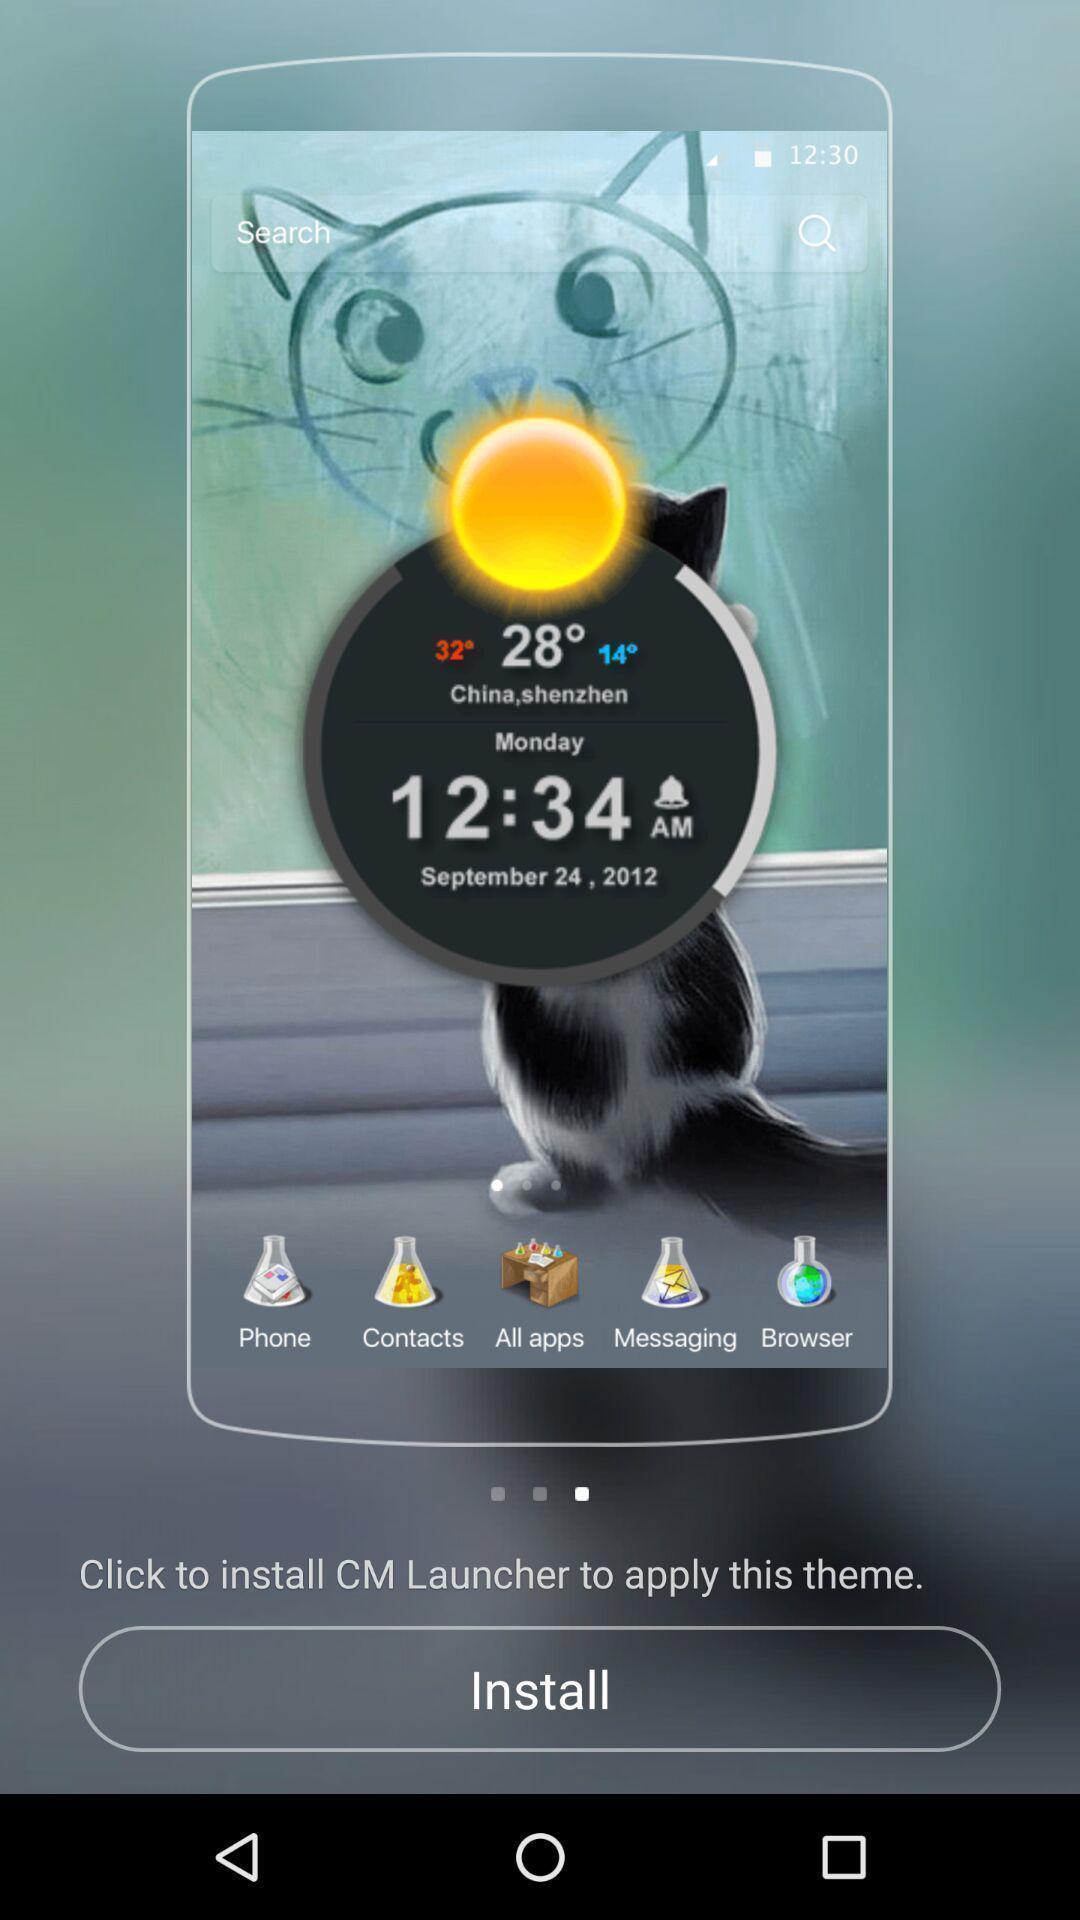What can you discern from this picture? Screen showing the welcome page of launcher. 